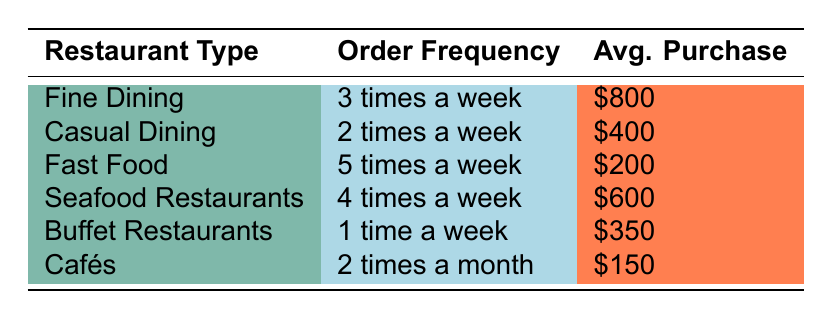What is the customer order frequency for Fast Food restaurants? The table indicates that Fast Food restaurants have a customer order frequency of 5 times a week.
Answer: 5 times a week Which restaurant type has the highest average purchase value? By comparing the average purchase values listed for each restaurant type, Fine Dining at $800 is the highest value among all.
Answer: Fine Dining Is the average purchase value for Casual Dining more than $500? The average purchase value for Casual Dining is $400, which is less than $500.
Answer: No How many times a week do Seafood Restaurants order? The table shows that Seafood Restaurants have a customer order frequency of 4 times a week.
Answer: 4 times a week What is the difference in average purchase value between Buffet Restaurants and Cafés? Buffet Restaurants have an average purchase value of $350, while Cafés have $150. The difference is $350 - $150 = $200.
Answer: $200 Do Cafés order more frequently than Buffet Restaurants? According to the frequency, Cafés order 2 times a month (approximately 0.5 times a week), while Buffet Restaurants order 1 time a week. Therefore, Buffet Restaurants order more frequently.
Answer: No What is the total average purchase value for Fine Dining and Seafood Restaurants combined? Fine Dining's average purchase value is $800 and Seafood Restaurants' is $600. Adding these together gives $800 + $600 = $1,400.
Answer: $1,400 Which restaurant type has the lowest customer order frequency? By inspecting the order frequencies, Buffet Restaurants order 1 time a week, which is the lowest frequency compared to all other restaurant types.
Answer: Buffet Restaurants What is the average customer order frequency across all restaurant types? To find the average, convert frequencies to a weekly scale: Fine Dining (3), Casual Dining (2), Fast Food (5), Seafood Restaurants (4), Buffet Restaurants (1), Cafés (0.5). The total is 3 + 2 + 5 + 4 + 1 + 0.5 = 15. There are 6 restaurant types, so the average frequency is 15 / 6 = 2.5.
Answer: 2.5 times a week 